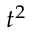Convert formula to latex. <formula><loc_0><loc_0><loc_500><loc_500>t ^ { 2 }</formula> 